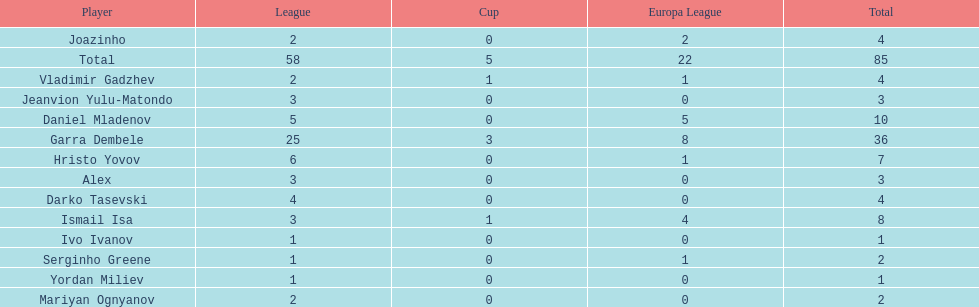Which players have at least 4 in the europa league? Garra Dembele, Daniel Mladenov, Ismail Isa. 